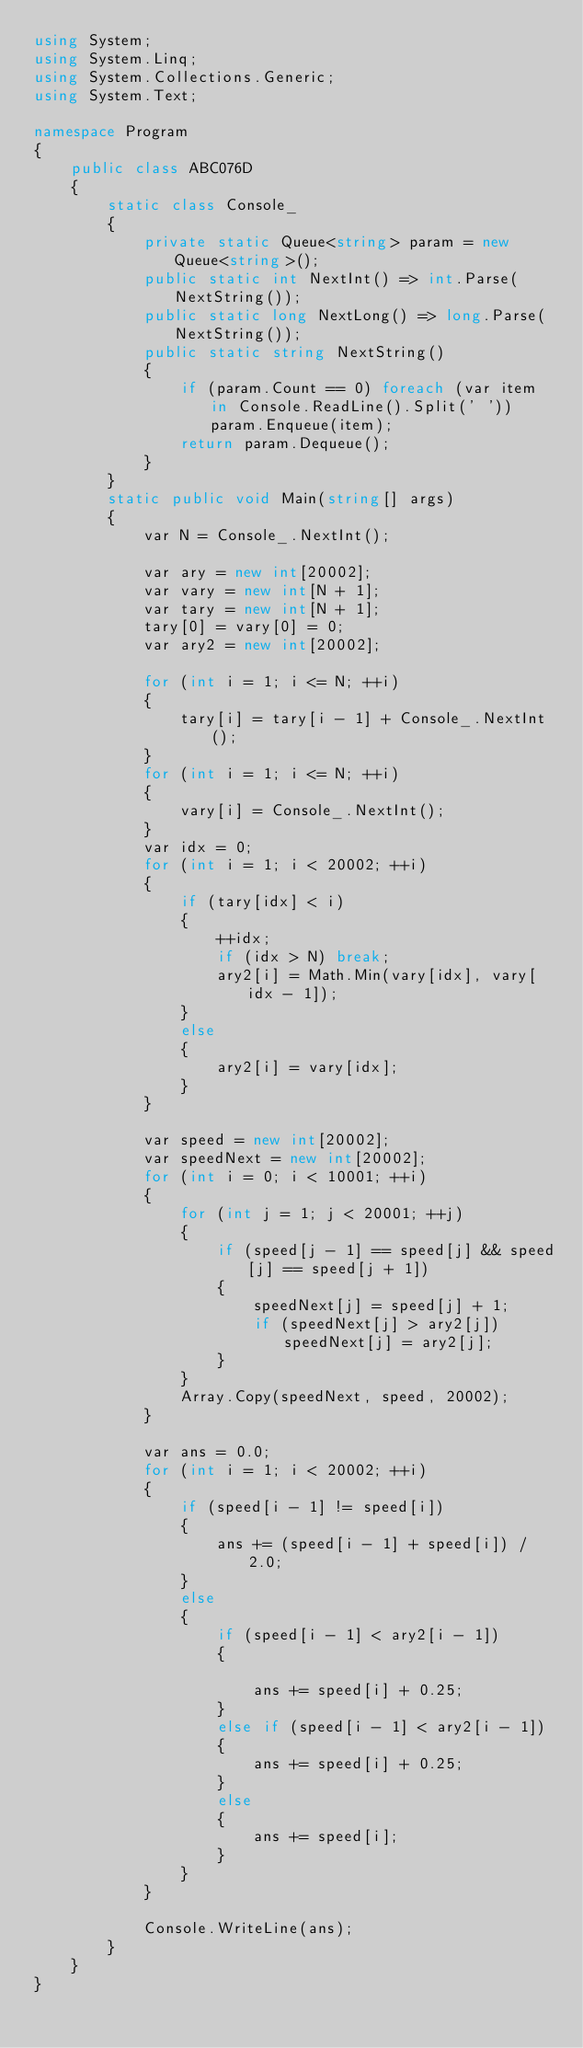<code> <loc_0><loc_0><loc_500><loc_500><_C#_>using System;
using System.Linq;
using System.Collections.Generic;
using System.Text;

namespace Program
{
    public class ABC076D
    {
        static class Console_
        {
            private static Queue<string> param = new Queue<string>();
            public static int NextInt() => int.Parse(NextString());
            public static long NextLong() => long.Parse(NextString());
            public static string NextString()
            {
                if (param.Count == 0) foreach (var item in Console.ReadLine().Split(' ')) param.Enqueue(item);
                return param.Dequeue();
            }
        }
        static public void Main(string[] args)
        {
            var N = Console_.NextInt();

            var ary = new int[20002];
            var vary = new int[N + 1];
            var tary = new int[N + 1];
            tary[0] = vary[0] = 0;
            var ary2 = new int[20002];

            for (int i = 1; i <= N; ++i)
            {
                tary[i] = tary[i - 1] + Console_.NextInt();
            }
            for (int i = 1; i <= N; ++i)
            {
                vary[i] = Console_.NextInt();
            }
            var idx = 0;
            for (int i = 1; i < 20002; ++i)
            {
                if (tary[idx] < i)
                {
                    ++idx;
                    if (idx > N) break;
                    ary2[i] = Math.Min(vary[idx], vary[idx - 1]);
                }
                else
                {
                    ary2[i] = vary[idx];
                }
            }

            var speed = new int[20002];
            var speedNext = new int[20002];
            for (int i = 0; i < 10001; ++i)
            {
                for (int j = 1; j < 20001; ++j)
                {
                    if (speed[j - 1] == speed[j] && speed[j] == speed[j + 1])
                    {
                        speedNext[j] = speed[j] + 1;
                        if (speedNext[j] > ary2[j]) speedNext[j] = ary2[j];
                    }
                }
                Array.Copy(speedNext, speed, 20002);
            }

            var ans = 0.0;
            for (int i = 1; i < 20002; ++i)
            {
                if (speed[i - 1] != speed[i])
                {
                    ans += (speed[i - 1] + speed[i]) / 2.0;
                }
                else
                {
                    if (speed[i - 1] < ary2[i - 1])
                    {

                        ans += speed[i] + 0.25;
                    }
                    else if (speed[i - 1] < ary2[i - 1])
                    {
                        ans += speed[i] + 0.25;
                    }
                    else
                    {
                        ans += speed[i];
                    }
                }
            }

            Console.WriteLine(ans);
        }
    }
}
</code> 